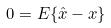Convert formula to latex. <formula><loc_0><loc_0><loc_500><loc_500>0 = E \{ \hat { x } - x \}</formula> 